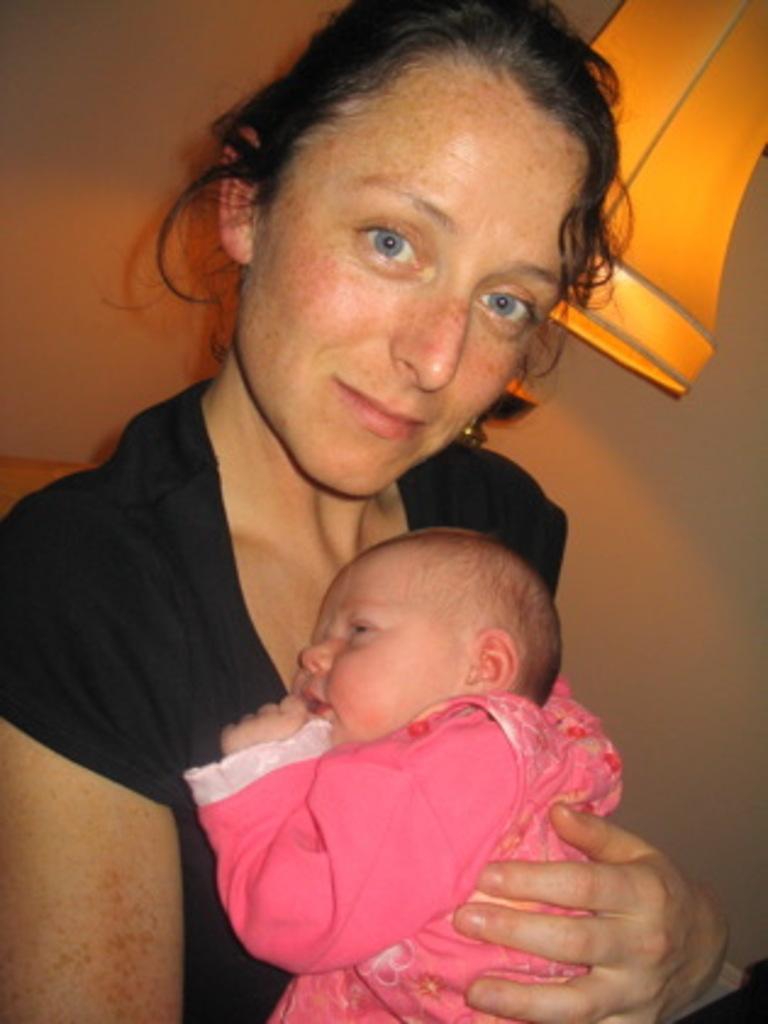In one or two sentences, can you explain what this image depicts? In this picture we can see a woman holding a baby in her hands. A lamp and a wall is visible in the background. 